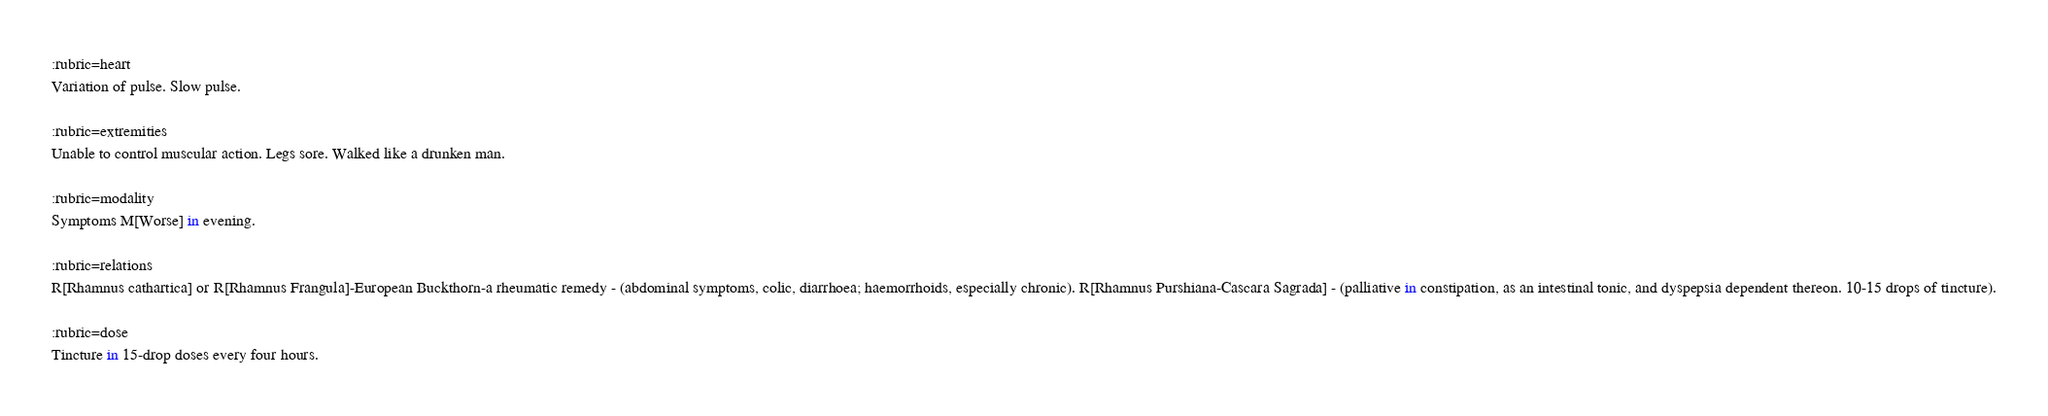Convert code to text. <code><loc_0><loc_0><loc_500><loc_500><_ObjectiveC_>
:rubric=heart
Variation of pulse. Slow pulse.

:rubric=extremities
Unable to control muscular action. Legs sore. Walked like a drunken man.

:rubric=modality
Symptoms M[Worse] in evening.

:rubric=relations
R[Rhamnus cathartica] or R[Rhamnus Frangula]-European Buckthorn-a rheumatic remedy - (abdominal symptoms, colic, diarrhoea; haemorrhoids, especially chronic). R[Rhamnus Purshiana-Cascara Sagrada] - (palliative in constipation, as an intestinal tonic, and dyspepsia dependent thereon. 10-15 drops of tincture).

:rubric=dose
Tincture in 15-drop doses every four hours.

</code> 